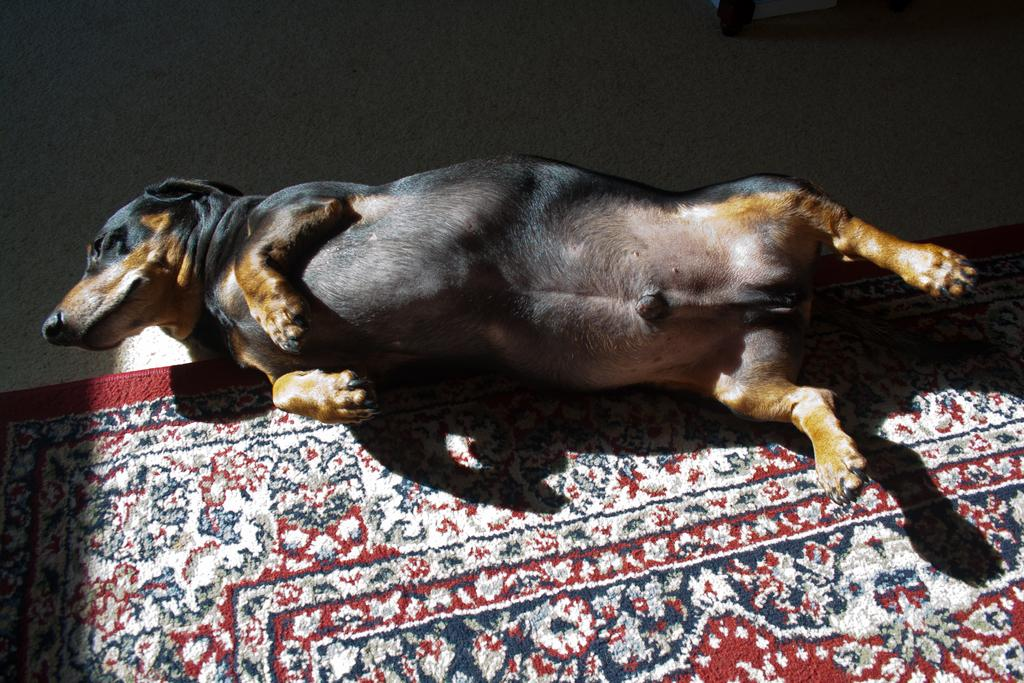What animal is present in the image? There is a dog in the image. What is the dog doing in the image? The dog is laying on a floor mat. What is the name of the chicken in the image? There is no chicken present in the image; it features a dog laying on a floor mat. 